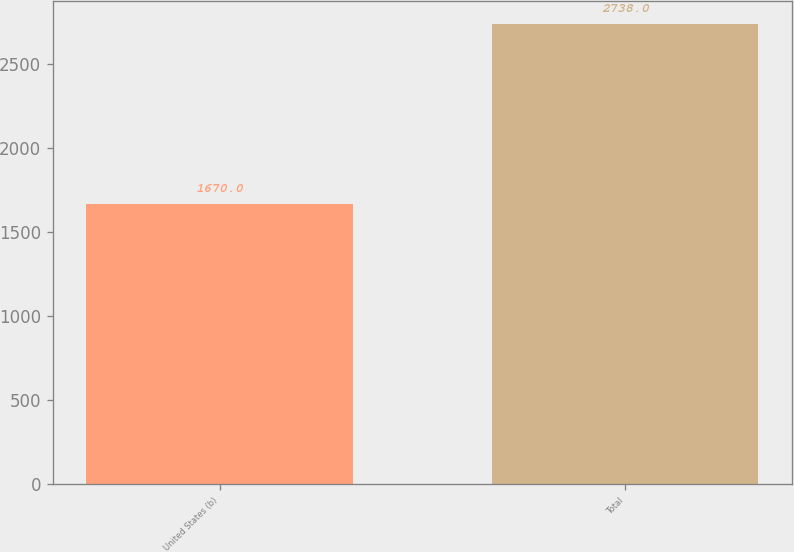<chart> <loc_0><loc_0><loc_500><loc_500><bar_chart><fcel>United States (b)<fcel>Total<nl><fcel>1670<fcel>2738<nl></chart> 